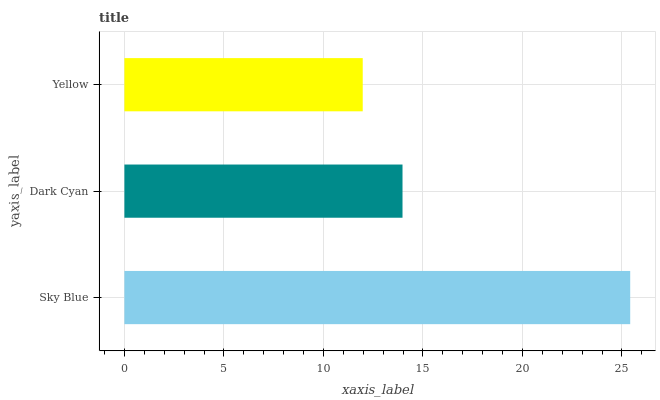Is Yellow the minimum?
Answer yes or no. Yes. Is Sky Blue the maximum?
Answer yes or no. Yes. Is Dark Cyan the minimum?
Answer yes or no. No. Is Dark Cyan the maximum?
Answer yes or no. No. Is Sky Blue greater than Dark Cyan?
Answer yes or no. Yes. Is Dark Cyan less than Sky Blue?
Answer yes or no. Yes. Is Dark Cyan greater than Sky Blue?
Answer yes or no. No. Is Sky Blue less than Dark Cyan?
Answer yes or no. No. Is Dark Cyan the high median?
Answer yes or no. Yes. Is Dark Cyan the low median?
Answer yes or no. Yes. Is Yellow the high median?
Answer yes or no. No. Is Sky Blue the low median?
Answer yes or no. No. 